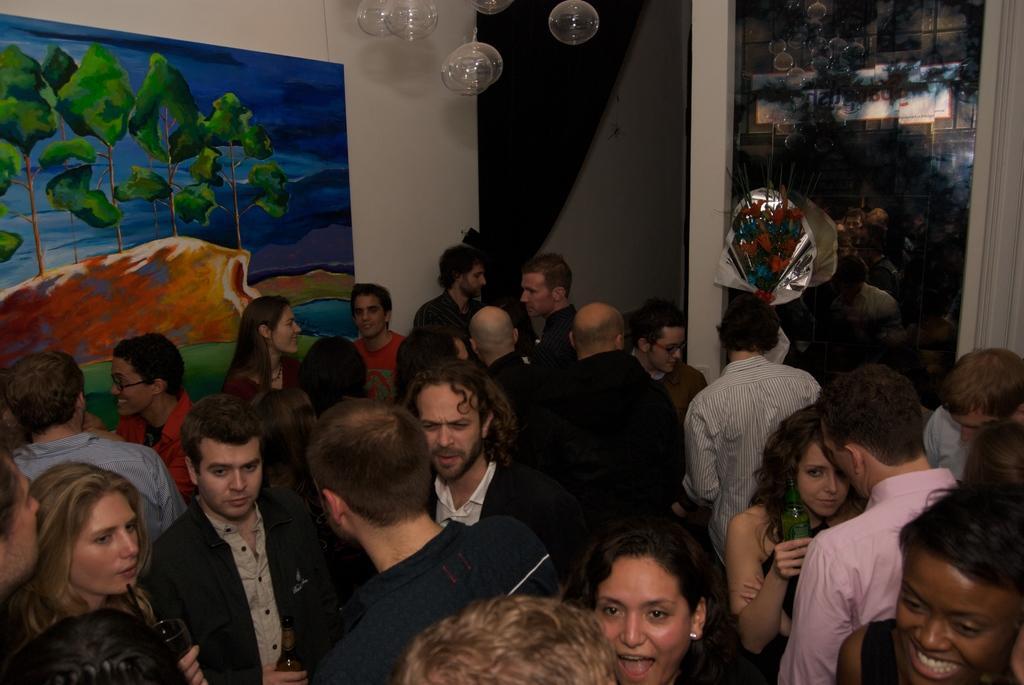Could you give a brief overview of what you see in this image? In this image I can see number of persons are standing on the floor. I can see the wall, a board attached to the wall, few glass objects hanged and a glass window through which I can see another building. 